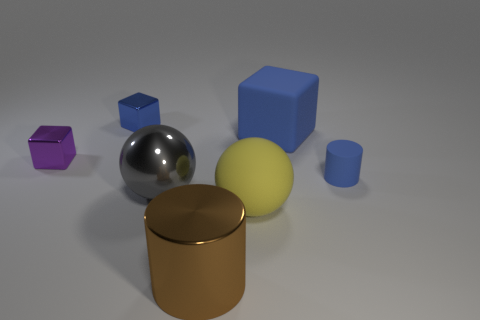Subtract all blue cubes. How many cubes are left? 1 Subtract all brown balls. How many blue cubes are left? 2 Subtract all yellow spheres. How many spheres are left? 1 Add 1 brown shiny cylinders. How many objects exist? 8 Subtract 1 balls. How many balls are left? 1 Subtract all green blocks. Subtract all blue spheres. How many blocks are left? 3 Subtract all cylinders. How many objects are left? 5 Subtract all big cyan objects. Subtract all big shiny objects. How many objects are left? 5 Add 5 cylinders. How many cylinders are left? 7 Add 6 tiny blue rubber things. How many tiny blue rubber things exist? 7 